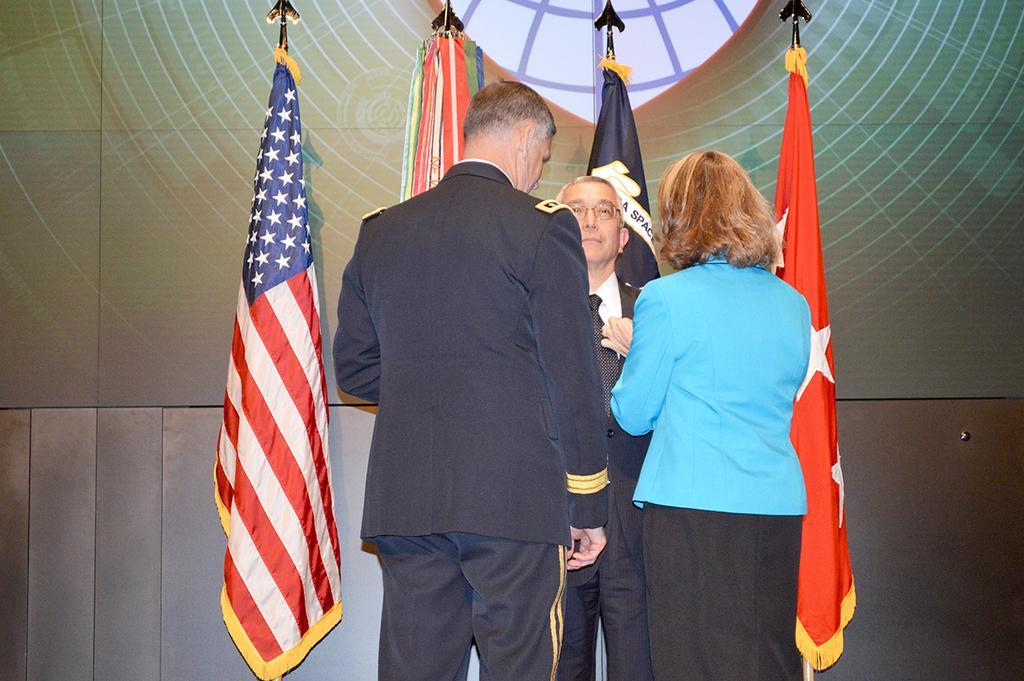Please provide a concise description of this image. In this picture we can see three persons standing here, a man in the middle wore a suit, we can see flags in the background. 